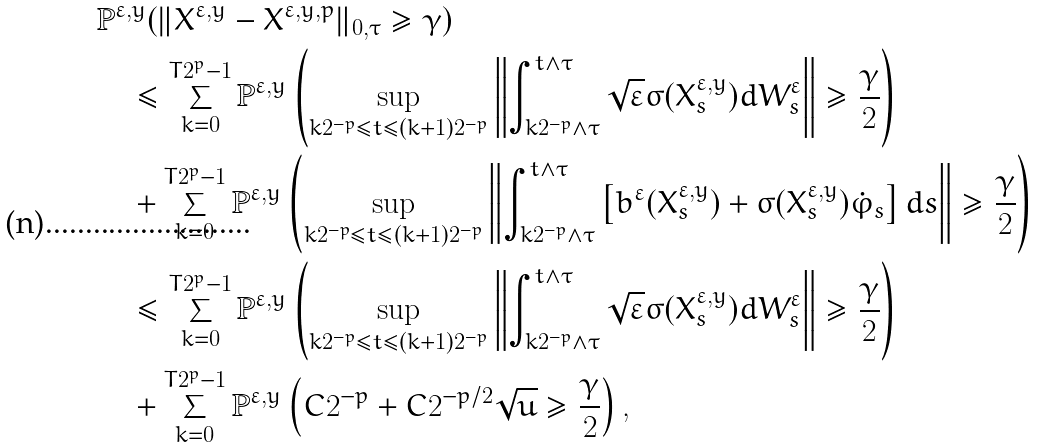Convert formula to latex. <formula><loc_0><loc_0><loc_500><loc_500>& { \mathbb { P } ^ { \varepsilon , y } ( \| { X } ^ { \varepsilon , y } - { X } ^ { \varepsilon , y , p } \| _ { 0 , \tau } \geq \gamma ) } \\ & \quad \leq \sum _ { k = 0 } ^ { T 2 ^ { p } - 1 } \mathbb { P } ^ { \varepsilon , y } \left ( \sup _ { k 2 ^ { - p } \leq t \leq ( k + 1 ) 2 ^ { - p } } \left \| \int _ { k 2 ^ { - p } \wedge \tau } ^ { t \wedge \tau } \sqrt { \varepsilon } \sigma ( { X } ^ { \varepsilon , y } _ { s } ) d W ^ { \varepsilon } _ { s } \right \| \geq \frac { \gamma } { 2 } \right ) \\ & \quad + \sum _ { k = 0 } ^ { T 2 ^ { p } - 1 } \mathbb { P } ^ { \varepsilon , y } \left ( \sup _ { k 2 ^ { - p } \leq t \leq ( k + 1 ) 2 ^ { - p } } \left \| \int _ { k 2 ^ { - p } \wedge \tau } ^ { t \wedge \tau } \left [ b ^ { \varepsilon } ( { X } ^ { \varepsilon , y } _ { s } ) + \sigma ( { X } ^ { \varepsilon , y } _ { s } ) \dot { \varphi } _ { s } \right ] d s \right \| \geq \frac { \gamma } { 2 } \right ) \\ & \quad \leq \sum _ { k = 0 } ^ { T 2 ^ { p } - 1 } \mathbb { P } ^ { \varepsilon , y } \left ( \sup _ { k 2 ^ { - p } \leq t \leq ( k + 1 ) 2 ^ { - p } } \left \| \int _ { k 2 ^ { - p } \wedge \tau } ^ { t \wedge \tau } \sqrt { \varepsilon } \sigma ( { X } ^ { \varepsilon , y } _ { s } ) d W ^ { \varepsilon } _ { s } \right \| \geq \frac { \gamma } { 2 } \right ) \\ & \quad + \sum _ { k = 0 } ^ { T 2 ^ { p } - 1 } \mathbb { P } ^ { \varepsilon , y } \left ( C 2 ^ { - p } + C 2 ^ { - p / 2 } \sqrt { u } \geq \frac { \gamma } { 2 } \right ) ,</formula> 